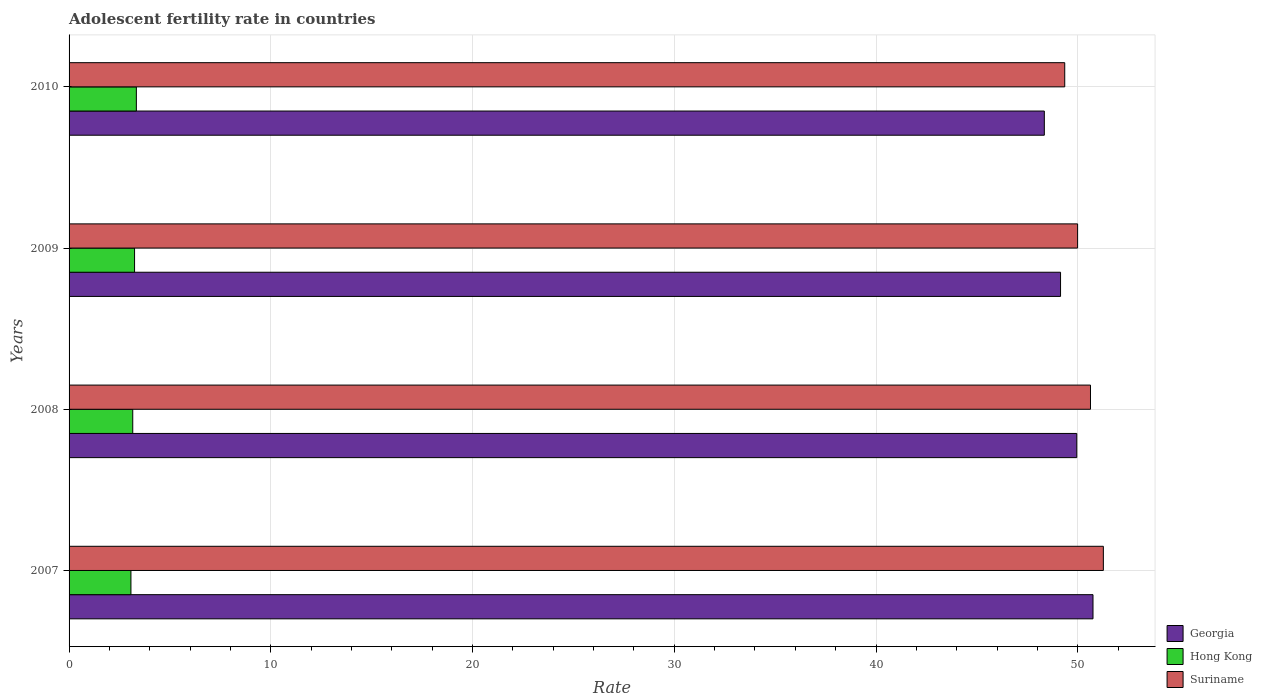How many groups of bars are there?
Keep it short and to the point. 4. Are the number of bars on each tick of the Y-axis equal?
Keep it short and to the point. Yes. What is the label of the 3rd group of bars from the top?
Your answer should be very brief. 2008. What is the adolescent fertility rate in Georgia in 2010?
Offer a terse response. 48.34. Across all years, what is the maximum adolescent fertility rate in Hong Kong?
Provide a short and direct response. 3.34. Across all years, what is the minimum adolescent fertility rate in Suriname?
Provide a short and direct response. 49.35. In which year was the adolescent fertility rate in Suriname minimum?
Your response must be concise. 2010. What is the total adolescent fertility rate in Hong Kong in the graph?
Provide a short and direct response. 12.81. What is the difference between the adolescent fertility rate in Suriname in 2007 and that in 2008?
Make the answer very short. 0.64. What is the difference between the adolescent fertility rate in Georgia in 2010 and the adolescent fertility rate in Suriname in 2008?
Keep it short and to the point. -2.29. What is the average adolescent fertility rate in Georgia per year?
Offer a very short reply. 49.55. In the year 2009, what is the difference between the adolescent fertility rate in Suriname and adolescent fertility rate in Hong Kong?
Offer a terse response. 46.75. What is the ratio of the adolescent fertility rate in Hong Kong in 2009 to that in 2010?
Ensure brevity in your answer.  0.97. Is the adolescent fertility rate in Hong Kong in 2007 less than that in 2008?
Offer a terse response. Yes. What is the difference between the highest and the second highest adolescent fertility rate in Georgia?
Your answer should be compact. 0.8. What is the difference between the highest and the lowest adolescent fertility rate in Suriname?
Your answer should be compact. 1.91. In how many years, is the adolescent fertility rate in Suriname greater than the average adolescent fertility rate in Suriname taken over all years?
Provide a succinct answer. 2. Is the sum of the adolescent fertility rate in Suriname in 2008 and 2010 greater than the maximum adolescent fertility rate in Hong Kong across all years?
Your answer should be compact. Yes. What does the 1st bar from the top in 2007 represents?
Provide a short and direct response. Suriname. What does the 1st bar from the bottom in 2009 represents?
Give a very brief answer. Georgia. How many bars are there?
Your answer should be very brief. 12. Are all the bars in the graph horizontal?
Give a very brief answer. Yes. What is the difference between two consecutive major ticks on the X-axis?
Your answer should be compact. 10. Does the graph contain any zero values?
Provide a succinct answer. No. Does the graph contain grids?
Give a very brief answer. Yes. Where does the legend appear in the graph?
Make the answer very short. Bottom right. How many legend labels are there?
Your response must be concise. 3. What is the title of the graph?
Give a very brief answer. Adolescent fertility rate in countries. Does "Afghanistan" appear as one of the legend labels in the graph?
Offer a terse response. No. What is the label or title of the X-axis?
Your response must be concise. Rate. What is the Rate in Georgia in 2007?
Keep it short and to the point. 50.76. What is the Rate in Hong Kong in 2007?
Your answer should be compact. 3.07. What is the Rate of Suriname in 2007?
Your answer should be very brief. 51.27. What is the Rate of Georgia in 2008?
Keep it short and to the point. 49.95. What is the Rate of Hong Kong in 2008?
Provide a short and direct response. 3.16. What is the Rate in Suriname in 2008?
Your response must be concise. 50.63. What is the Rate in Georgia in 2009?
Your answer should be compact. 49.15. What is the Rate of Hong Kong in 2009?
Offer a terse response. 3.25. What is the Rate of Suriname in 2009?
Offer a terse response. 49.99. What is the Rate in Georgia in 2010?
Ensure brevity in your answer.  48.34. What is the Rate in Hong Kong in 2010?
Your answer should be compact. 3.34. What is the Rate in Suriname in 2010?
Keep it short and to the point. 49.35. Across all years, what is the maximum Rate in Georgia?
Keep it short and to the point. 50.76. Across all years, what is the maximum Rate of Hong Kong?
Offer a very short reply. 3.34. Across all years, what is the maximum Rate of Suriname?
Offer a very short reply. 51.27. Across all years, what is the minimum Rate of Georgia?
Keep it short and to the point. 48.34. Across all years, what is the minimum Rate in Hong Kong?
Your answer should be compact. 3.07. Across all years, what is the minimum Rate of Suriname?
Give a very brief answer. 49.35. What is the total Rate of Georgia in the graph?
Make the answer very short. 198.2. What is the total Rate in Hong Kong in the graph?
Make the answer very short. 12.81. What is the total Rate of Suriname in the graph?
Your answer should be compact. 201.25. What is the difference between the Rate in Georgia in 2007 and that in 2008?
Your answer should be compact. 0.8. What is the difference between the Rate of Hong Kong in 2007 and that in 2008?
Offer a very short reply. -0.09. What is the difference between the Rate of Suriname in 2007 and that in 2008?
Offer a terse response. 0.64. What is the difference between the Rate of Georgia in 2007 and that in 2009?
Your response must be concise. 1.61. What is the difference between the Rate in Hong Kong in 2007 and that in 2009?
Provide a succinct answer. -0.18. What is the difference between the Rate of Suriname in 2007 and that in 2009?
Your response must be concise. 1.28. What is the difference between the Rate of Georgia in 2007 and that in 2010?
Make the answer very short. 2.41. What is the difference between the Rate of Hong Kong in 2007 and that in 2010?
Make the answer very short. -0.27. What is the difference between the Rate in Suriname in 2007 and that in 2010?
Provide a short and direct response. 1.91. What is the difference between the Rate in Georgia in 2008 and that in 2009?
Keep it short and to the point. 0.8. What is the difference between the Rate in Hong Kong in 2008 and that in 2009?
Provide a short and direct response. -0.09. What is the difference between the Rate in Suriname in 2008 and that in 2009?
Provide a short and direct response. 0.64. What is the difference between the Rate in Georgia in 2008 and that in 2010?
Give a very brief answer. 1.61. What is the difference between the Rate of Hong Kong in 2008 and that in 2010?
Your response must be concise. -0.18. What is the difference between the Rate in Suriname in 2008 and that in 2010?
Ensure brevity in your answer.  1.28. What is the difference between the Rate in Georgia in 2009 and that in 2010?
Offer a very short reply. 0.8. What is the difference between the Rate in Hong Kong in 2009 and that in 2010?
Provide a succinct answer. -0.09. What is the difference between the Rate of Suriname in 2009 and that in 2010?
Your response must be concise. 0.64. What is the difference between the Rate of Georgia in 2007 and the Rate of Hong Kong in 2008?
Provide a short and direct response. 47.6. What is the difference between the Rate of Georgia in 2007 and the Rate of Suriname in 2008?
Your response must be concise. 0.13. What is the difference between the Rate of Hong Kong in 2007 and the Rate of Suriname in 2008?
Provide a short and direct response. -47.56. What is the difference between the Rate in Georgia in 2007 and the Rate in Hong Kong in 2009?
Your answer should be compact. 47.51. What is the difference between the Rate of Georgia in 2007 and the Rate of Suriname in 2009?
Keep it short and to the point. 0.76. What is the difference between the Rate in Hong Kong in 2007 and the Rate in Suriname in 2009?
Make the answer very short. -46.93. What is the difference between the Rate in Georgia in 2007 and the Rate in Hong Kong in 2010?
Give a very brief answer. 47.42. What is the difference between the Rate of Georgia in 2007 and the Rate of Suriname in 2010?
Ensure brevity in your answer.  1.4. What is the difference between the Rate of Hong Kong in 2007 and the Rate of Suriname in 2010?
Offer a very short reply. -46.29. What is the difference between the Rate of Georgia in 2008 and the Rate of Hong Kong in 2009?
Keep it short and to the point. 46.71. What is the difference between the Rate of Georgia in 2008 and the Rate of Suriname in 2009?
Provide a succinct answer. -0.04. What is the difference between the Rate of Hong Kong in 2008 and the Rate of Suriname in 2009?
Your answer should be compact. -46.84. What is the difference between the Rate in Georgia in 2008 and the Rate in Hong Kong in 2010?
Provide a succinct answer. 46.62. What is the difference between the Rate of Georgia in 2008 and the Rate of Suriname in 2010?
Offer a terse response. 0.6. What is the difference between the Rate of Hong Kong in 2008 and the Rate of Suriname in 2010?
Provide a short and direct response. -46.2. What is the difference between the Rate in Georgia in 2009 and the Rate in Hong Kong in 2010?
Provide a succinct answer. 45.81. What is the difference between the Rate in Georgia in 2009 and the Rate in Suriname in 2010?
Give a very brief answer. -0.21. What is the difference between the Rate of Hong Kong in 2009 and the Rate of Suriname in 2010?
Provide a short and direct response. -46.11. What is the average Rate of Georgia per year?
Give a very brief answer. 49.55. What is the average Rate of Hong Kong per year?
Offer a terse response. 3.2. What is the average Rate of Suriname per year?
Your answer should be compact. 50.31. In the year 2007, what is the difference between the Rate in Georgia and Rate in Hong Kong?
Make the answer very short. 47.69. In the year 2007, what is the difference between the Rate of Georgia and Rate of Suriname?
Provide a short and direct response. -0.51. In the year 2007, what is the difference between the Rate in Hong Kong and Rate in Suriname?
Your answer should be compact. -48.2. In the year 2008, what is the difference between the Rate of Georgia and Rate of Hong Kong?
Give a very brief answer. 46.8. In the year 2008, what is the difference between the Rate in Georgia and Rate in Suriname?
Your response must be concise. -0.68. In the year 2008, what is the difference between the Rate in Hong Kong and Rate in Suriname?
Offer a terse response. -47.47. In the year 2009, what is the difference between the Rate of Georgia and Rate of Hong Kong?
Offer a very short reply. 45.9. In the year 2009, what is the difference between the Rate of Georgia and Rate of Suriname?
Give a very brief answer. -0.85. In the year 2009, what is the difference between the Rate of Hong Kong and Rate of Suriname?
Ensure brevity in your answer.  -46.75. In the year 2010, what is the difference between the Rate of Georgia and Rate of Hong Kong?
Your answer should be very brief. 45.01. In the year 2010, what is the difference between the Rate of Georgia and Rate of Suriname?
Give a very brief answer. -1.01. In the year 2010, what is the difference between the Rate of Hong Kong and Rate of Suriname?
Offer a terse response. -46.02. What is the ratio of the Rate in Georgia in 2007 to that in 2008?
Provide a succinct answer. 1.02. What is the ratio of the Rate of Hong Kong in 2007 to that in 2008?
Provide a succinct answer. 0.97. What is the ratio of the Rate in Suriname in 2007 to that in 2008?
Your answer should be compact. 1.01. What is the ratio of the Rate of Georgia in 2007 to that in 2009?
Provide a succinct answer. 1.03. What is the ratio of the Rate in Hong Kong in 2007 to that in 2009?
Ensure brevity in your answer.  0.94. What is the ratio of the Rate of Suriname in 2007 to that in 2009?
Make the answer very short. 1.03. What is the ratio of the Rate in Georgia in 2007 to that in 2010?
Give a very brief answer. 1.05. What is the ratio of the Rate of Hong Kong in 2007 to that in 2010?
Provide a short and direct response. 0.92. What is the ratio of the Rate in Suriname in 2007 to that in 2010?
Your answer should be very brief. 1.04. What is the ratio of the Rate of Georgia in 2008 to that in 2009?
Your response must be concise. 1.02. What is the ratio of the Rate in Hong Kong in 2008 to that in 2009?
Your answer should be very brief. 0.97. What is the ratio of the Rate in Suriname in 2008 to that in 2009?
Keep it short and to the point. 1.01. What is the ratio of the Rate of Georgia in 2008 to that in 2010?
Keep it short and to the point. 1.03. What is the ratio of the Rate of Hong Kong in 2008 to that in 2010?
Offer a terse response. 0.95. What is the ratio of the Rate of Suriname in 2008 to that in 2010?
Offer a very short reply. 1.03. What is the ratio of the Rate in Georgia in 2009 to that in 2010?
Ensure brevity in your answer.  1.02. What is the ratio of the Rate of Hong Kong in 2009 to that in 2010?
Your answer should be very brief. 0.97. What is the ratio of the Rate in Suriname in 2009 to that in 2010?
Keep it short and to the point. 1.01. What is the difference between the highest and the second highest Rate of Georgia?
Give a very brief answer. 0.8. What is the difference between the highest and the second highest Rate of Hong Kong?
Your response must be concise. 0.09. What is the difference between the highest and the second highest Rate of Suriname?
Offer a very short reply. 0.64. What is the difference between the highest and the lowest Rate in Georgia?
Your response must be concise. 2.41. What is the difference between the highest and the lowest Rate in Hong Kong?
Your answer should be compact. 0.27. What is the difference between the highest and the lowest Rate of Suriname?
Your answer should be compact. 1.91. 